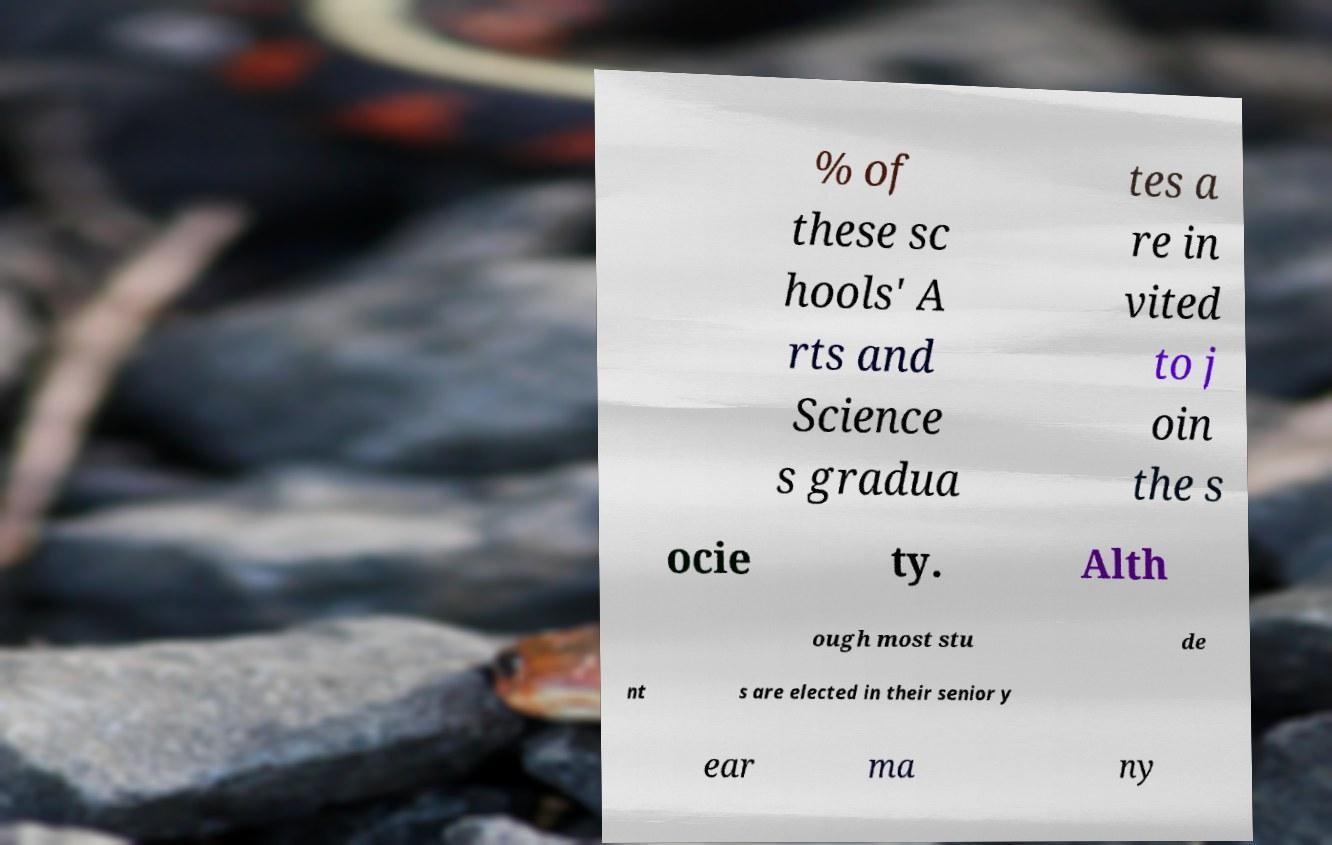What messages or text are displayed in this image? I need them in a readable, typed format. % of these sc hools' A rts and Science s gradua tes a re in vited to j oin the s ocie ty. Alth ough most stu de nt s are elected in their senior y ear ma ny 